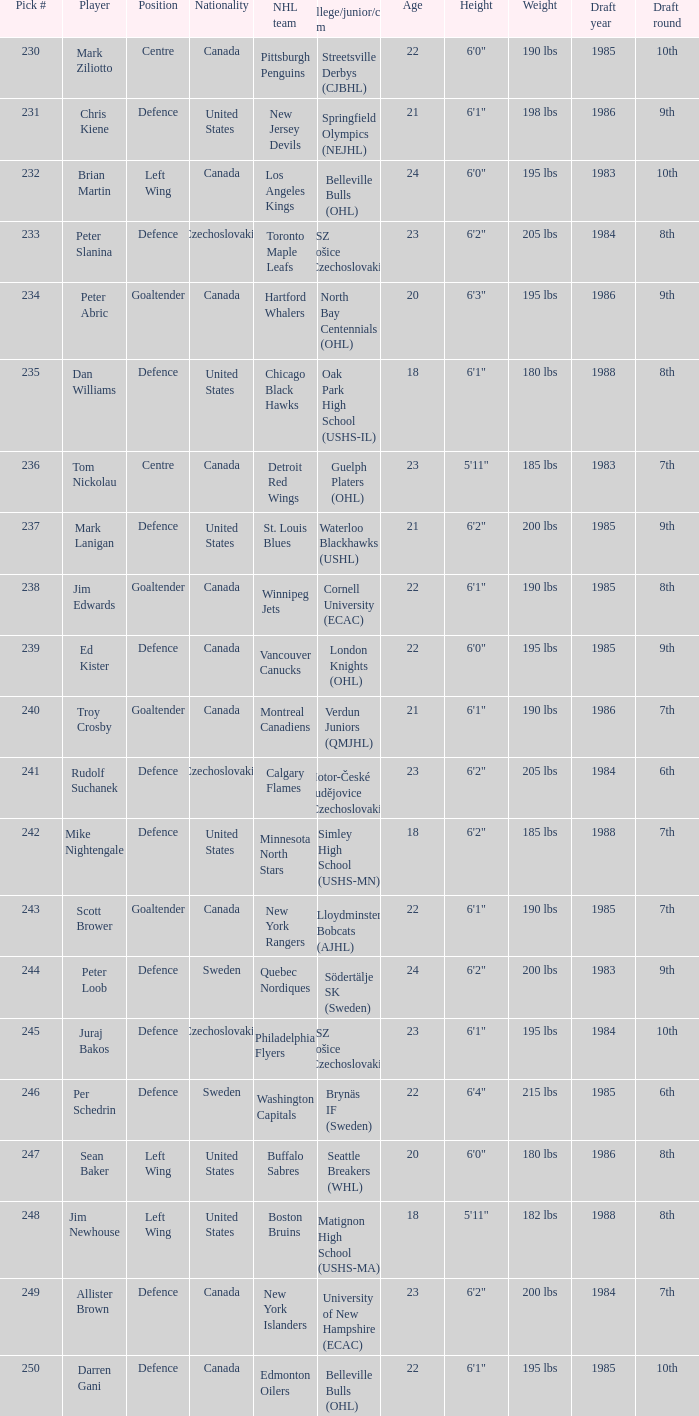To which organziation does the  winnipeg jets belong to? Cornell University (ECAC). 